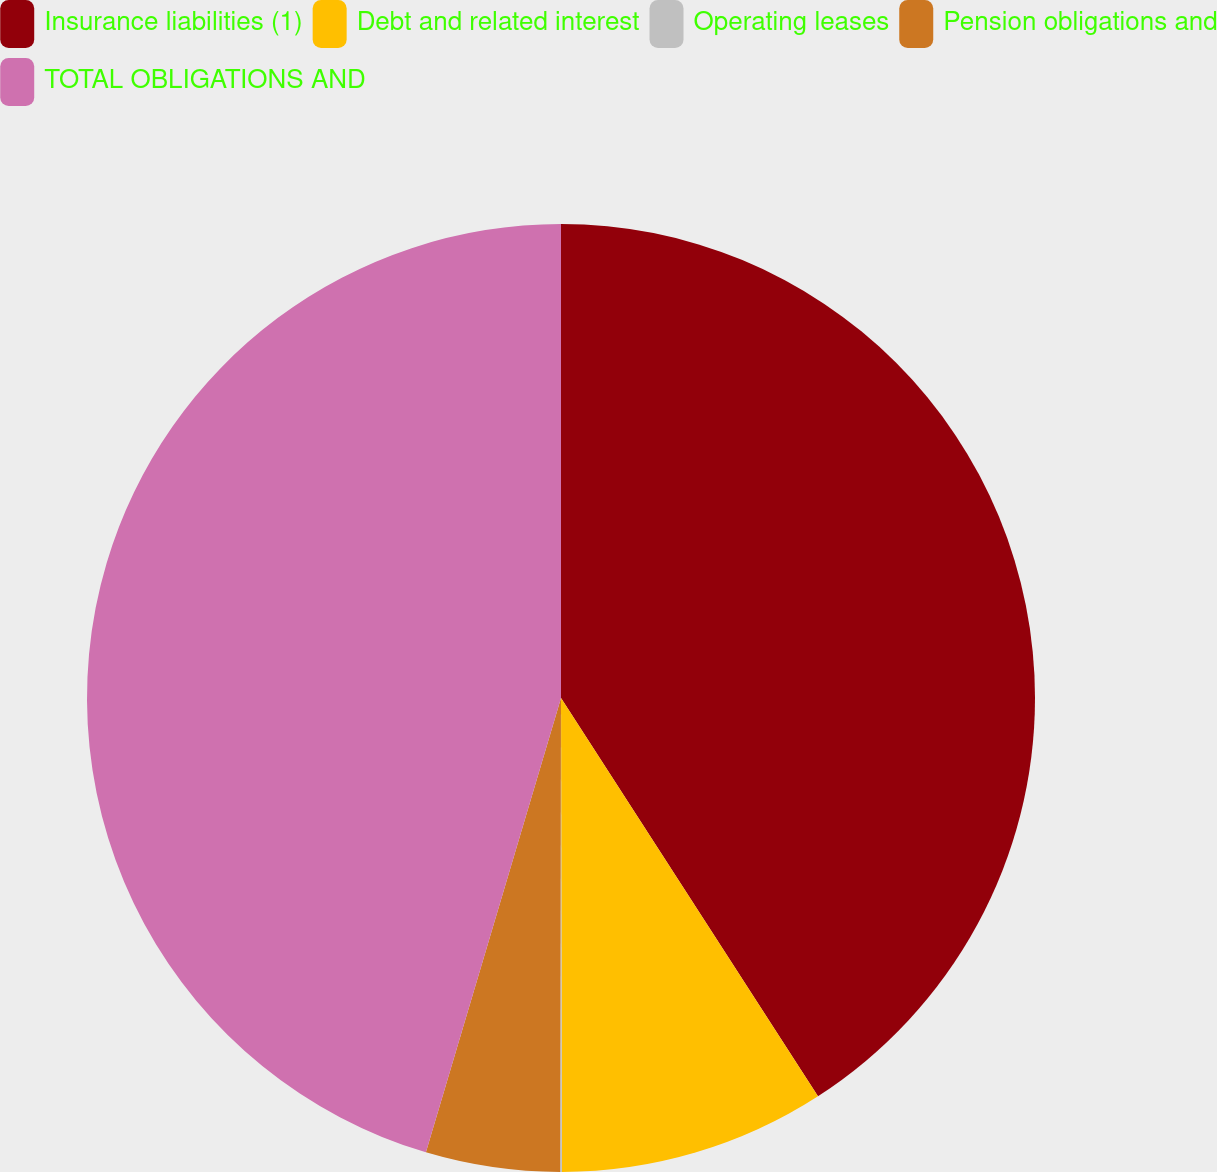Convert chart to OTSL. <chart><loc_0><loc_0><loc_500><loc_500><pie_chart><fcel>Insurance liabilities (1)<fcel>Debt and related interest<fcel>Operating leases<fcel>Pension obligations and<fcel>TOTAL OBLIGATIONS AND<nl><fcel>40.88%<fcel>9.09%<fcel>0.06%<fcel>4.57%<fcel>45.4%<nl></chart> 